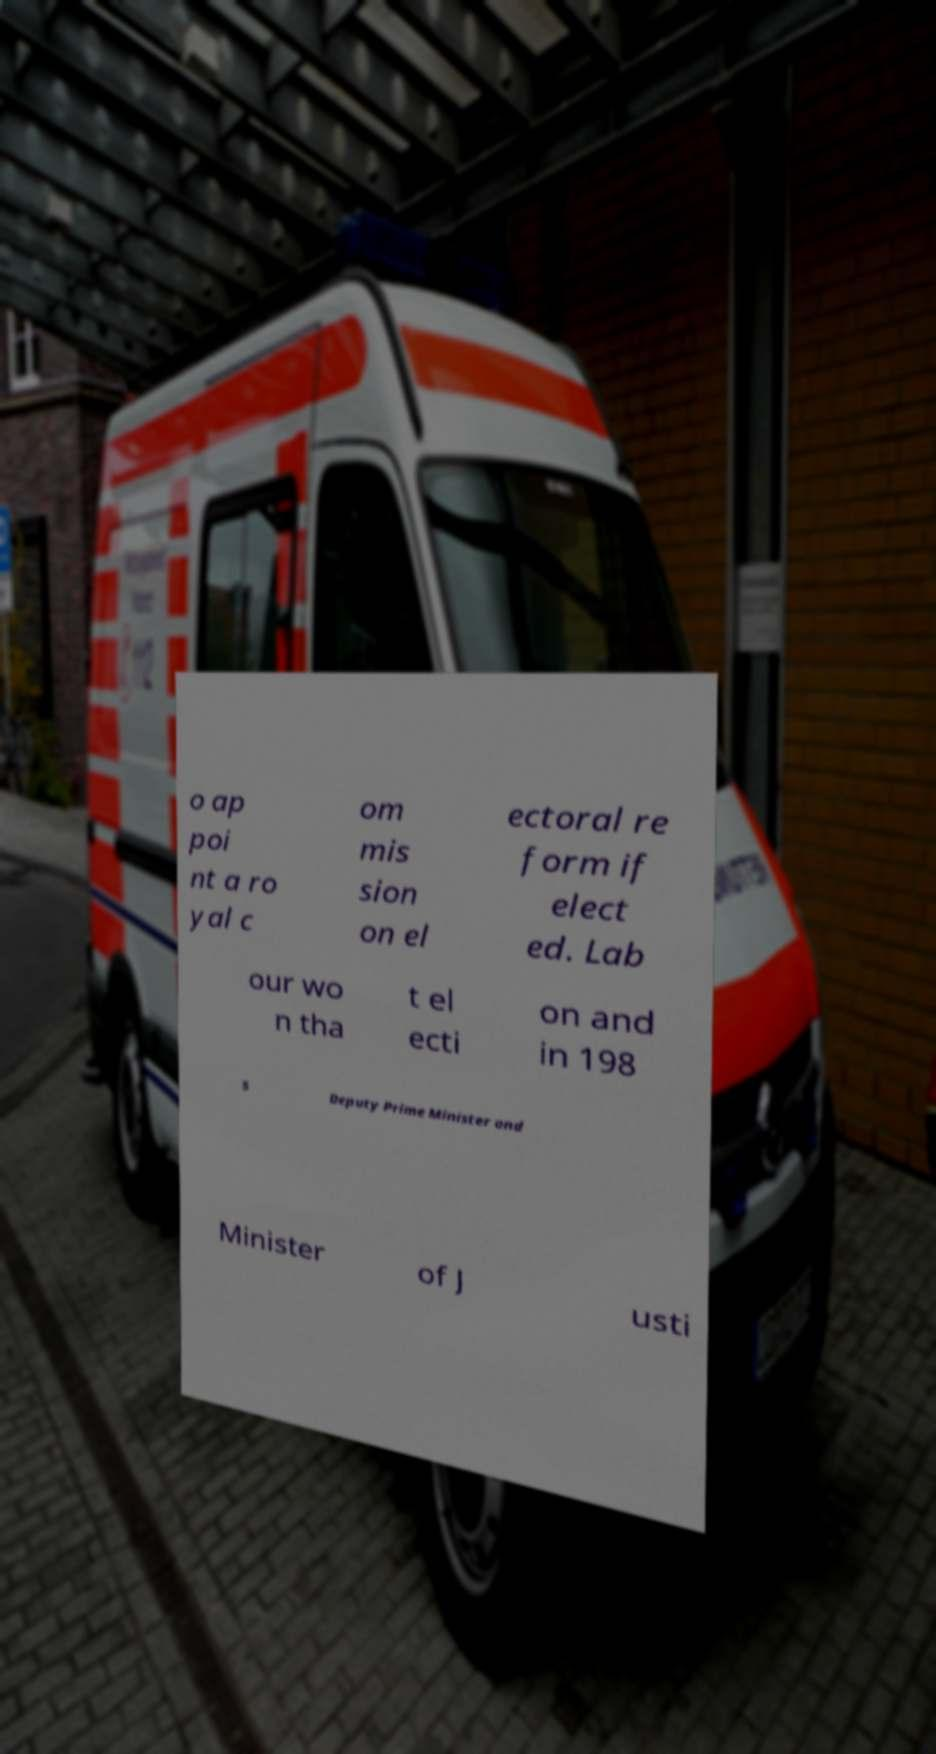Could you assist in decoding the text presented in this image and type it out clearly? o ap poi nt a ro yal c om mis sion on el ectoral re form if elect ed. Lab our wo n tha t el ecti on and in 198 5 Deputy Prime Minister and Minister of J usti 